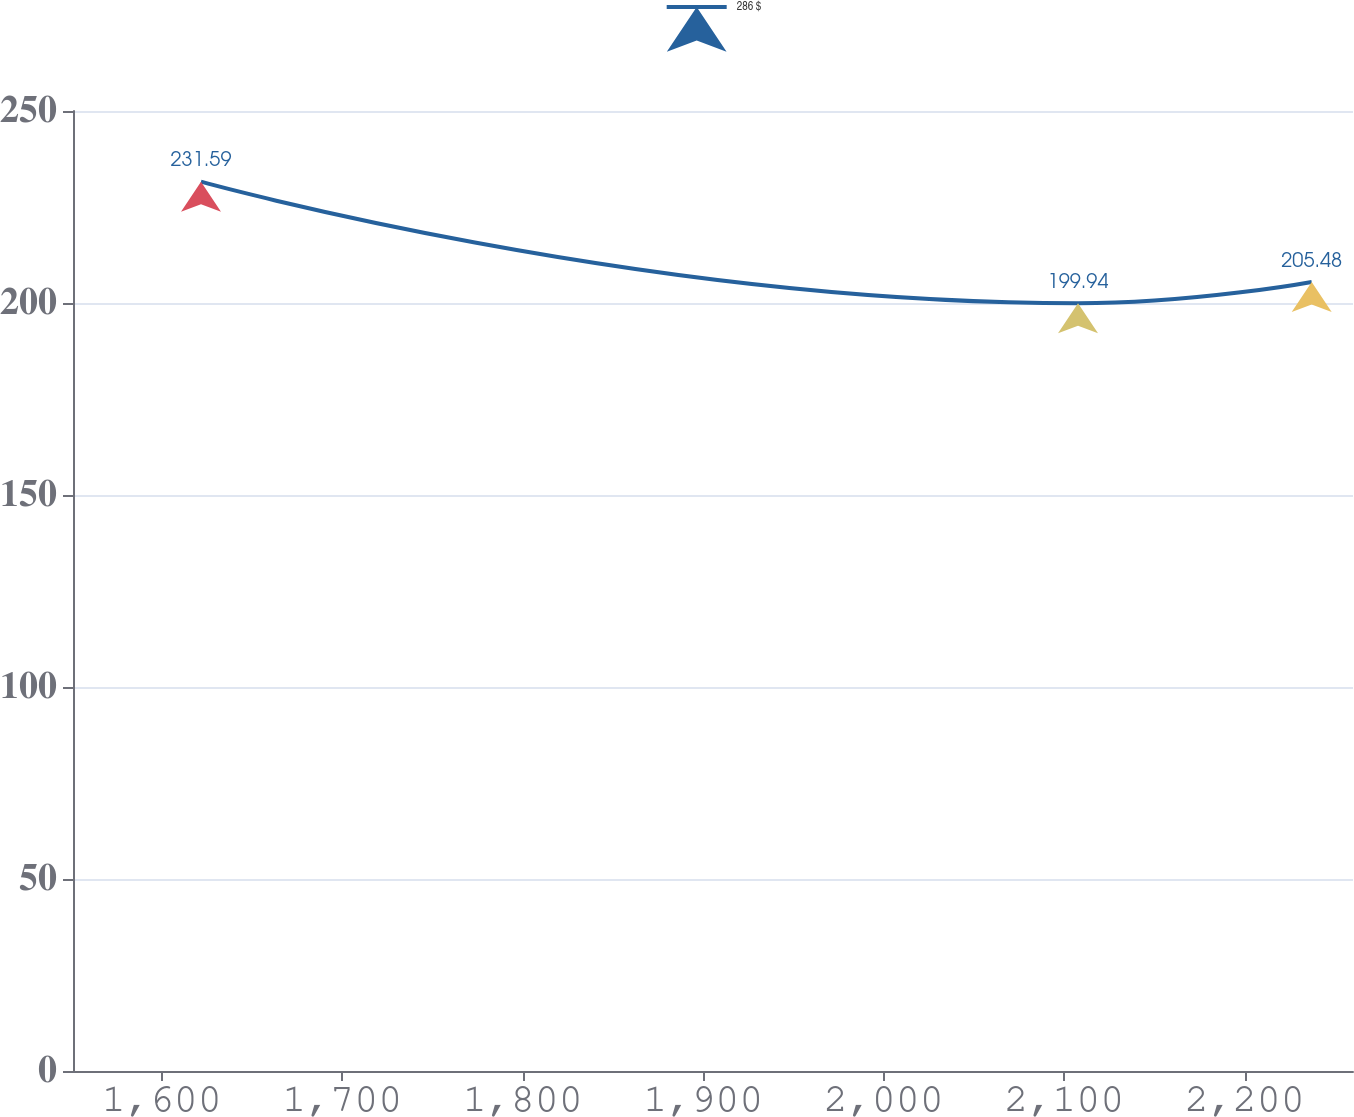Convert chart. <chart><loc_0><loc_0><loc_500><loc_500><line_chart><ecel><fcel>286 $<nl><fcel>1621.76<fcel>231.59<nl><fcel>2107.64<fcel>199.94<nl><fcel>2237.1<fcel>205.48<nl><fcel>2330.9<fcel>176.17<nl></chart> 